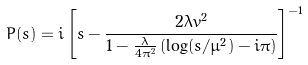<formula> <loc_0><loc_0><loc_500><loc_500>P ( s ) = i \left [ s - \frac { 2 \lambda v ^ { 2 } } { 1 - \frac { \lambda } { 4 \pi ^ { 2 } } \left ( \log ( s / \mu ^ { 2 } ) - i \pi \right ) } \right ] ^ { - 1 }</formula> 